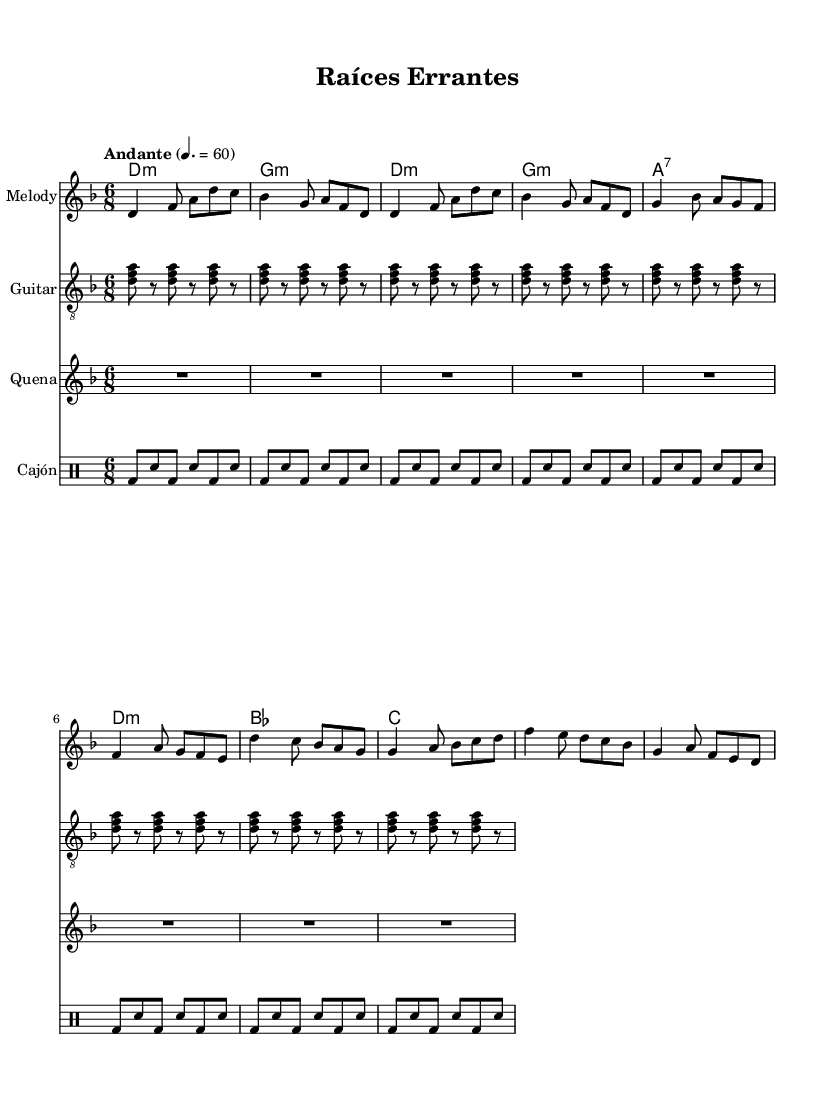What is the key signature of this music? The key signature is D minor, which has one flat (B flat). This can be derived from the key indicated at the beginning of the score.
Answer: D minor What is the time signature of this music? The time signature is 6/8, as indicated in the score. This means there are six eighth notes per measure.
Answer: 6/8 What is the tempo marking of this piece? The tempo marking is Andante, which indicates a moderately slow tempo. This is found in the tempo indication at the beginning of the score.
Answer: Andante How many measures are in the melody section? The melody section consists of 16 measures, as counted from the beginning of the melody line to the end of the chorus.
Answer: 16 Which instrument plays the melody? The instrument that plays the melody is the "Melody," as labeled in the score. This staff specifically indicates it is the main melodic line.
Answer: Melody What harmonic structure is used in the chorus? The harmonic structure in the chorus follows a progression of D minor, C, and G major, as seen in the chord mode section under the chorus line in the score.
Answer: D minor, C, G major What type of rhythm is primarily used in the Cajón part? The Cajón part primarily uses a basic alternating rhythm pattern of bass and snare, indicated by bd (bass drum) and sn (snare). This pattern is repeated throughout the specified measures.
Answer: Alternating bass and snare rhythm 